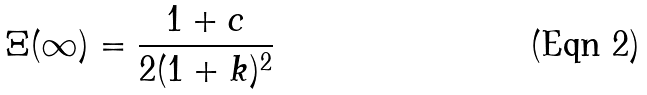<formula> <loc_0><loc_0><loc_500><loc_500>\Xi ( \infty ) = \frac { 1 + c } { 2 ( 1 + k ) ^ { 2 } }</formula> 